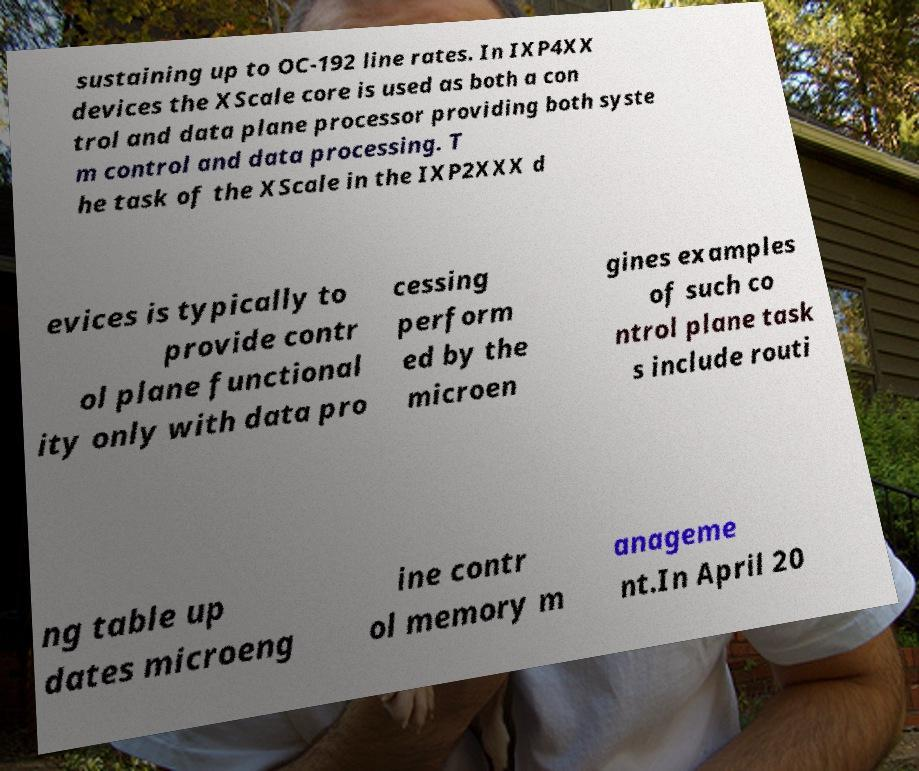Please identify and transcribe the text found in this image. sustaining up to OC-192 line rates. In IXP4XX devices the XScale core is used as both a con trol and data plane processor providing both syste m control and data processing. T he task of the XScale in the IXP2XXX d evices is typically to provide contr ol plane functional ity only with data pro cessing perform ed by the microen gines examples of such co ntrol plane task s include routi ng table up dates microeng ine contr ol memory m anageme nt.In April 20 